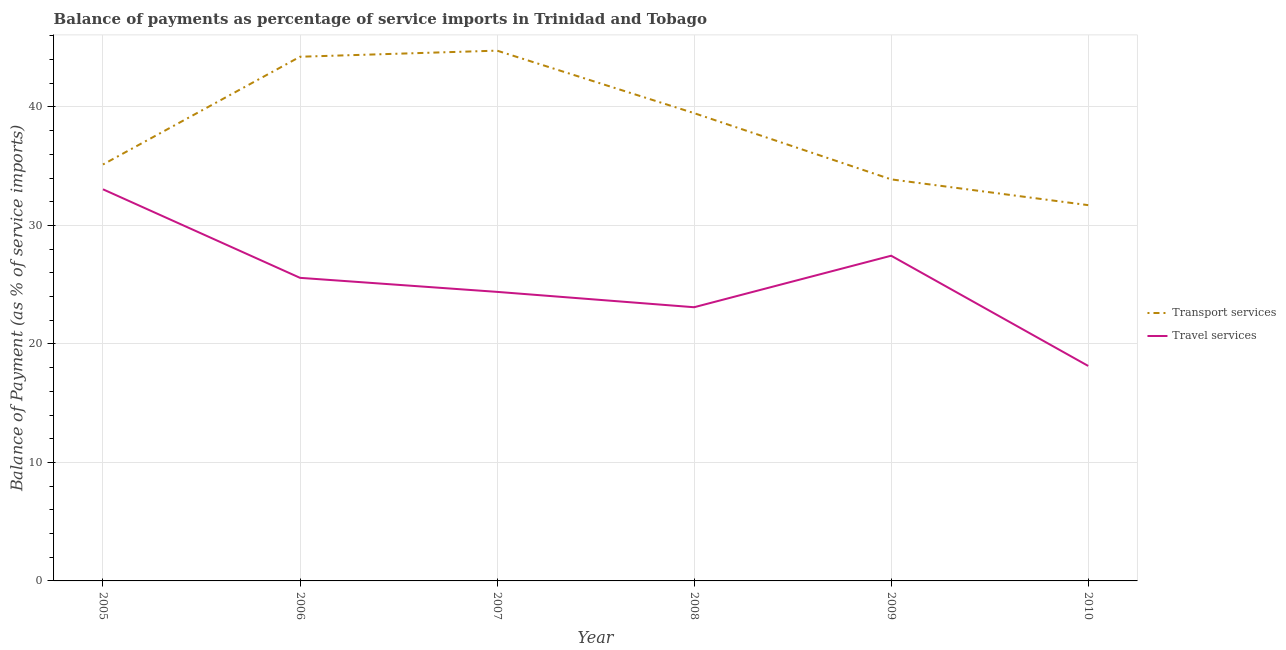Does the line corresponding to balance of payments of transport services intersect with the line corresponding to balance of payments of travel services?
Keep it short and to the point. No. Is the number of lines equal to the number of legend labels?
Keep it short and to the point. Yes. What is the balance of payments of travel services in 2009?
Provide a short and direct response. 27.45. Across all years, what is the maximum balance of payments of travel services?
Provide a short and direct response. 33.05. Across all years, what is the minimum balance of payments of transport services?
Your response must be concise. 31.71. What is the total balance of payments of travel services in the graph?
Ensure brevity in your answer.  151.71. What is the difference between the balance of payments of transport services in 2008 and that in 2009?
Provide a succinct answer. 5.59. What is the difference between the balance of payments of transport services in 2010 and the balance of payments of travel services in 2009?
Give a very brief answer. 4.27. What is the average balance of payments of travel services per year?
Offer a very short reply. 25.29. In the year 2008, what is the difference between the balance of payments of travel services and balance of payments of transport services?
Ensure brevity in your answer.  -16.38. In how many years, is the balance of payments of transport services greater than 10 %?
Give a very brief answer. 6. What is the ratio of the balance of payments of transport services in 2007 to that in 2008?
Your response must be concise. 1.13. Is the difference between the balance of payments of travel services in 2006 and 2007 greater than the difference between the balance of payments of transport services in 2006 and 2007?
Ensure brevity in your answer.  Yes. What is the difference between the highest and the second highest balance of payments of transport services?
Provide a short and direct response. 0.51. What is the difference between the highest and the lowest balance of payments of transport services?
Offer a very short reply. 13.04. Is the sum of the balance of payments of travel services in 2009 and 2010 greater than the maximum balance of payments of transport services across all years?
Your answer should be compact. Yes. Does the balance of payments of travel services monotonically increase over the years?
Your answer should be compact. No. Is the balance of payments of transport services strictly less than the balance of payments of travel services over the years?
Your answer should be compact. No. How many lines are there?
Offer a very short reply. 2. Are the values on the major ticks of Y-axis written in scientific E-notation?
Your response must be concise. No. Does the graph contain any zero values?
Make the answer very short. No. How are the legend labels stacked?
Your answer should be very brief. Vertical. What is the title of the graph?
Offer a terse response. Balance of payments as percentage of service imports in Trinidad and Tobago. Does "Travel Items" appear as one of the legend labels in the graph?
Offer a terse response. No. What is the label or title of the X-axis?
Make the answer very short. Year. What is the label or title of the Y-axis?
Offer a very short reply. Balance of Payment (as % of service imports). What is the Balance of Payment (as % of service imports) of Transport services in 2005?
Give a very brief answer. 35.15. What is the Balance of Payment (as % of service imports) of Travel services in 2005?
Provide a short and direct response. 33.05. What is the Balance of Payment (as % of service imports) in Transport services in 2006?
Provide a succinct answer. 44.24. What is the Balance of Payment (as % of service imports) in Travel services in 2006?
Provide a short and direct response. 25.58. What is the Balance of Payment (as % of service imports) in Transport services in 2007?
Your response must be concise. 44.75. What is the Balance of Payment (as % of service imports) in Travel services in 2007?
Keep it short and to the point. 24.39. What is the Balance of Payment (as % of service imports) of Transport services in 2008?
Offer a terse response. 39.48. What is the Balance of Payment (as % of service imports) of Travel services in 2008?
Ensure brevity in your answer.  23.1. What is the Balance of Payment (as % of service imports) of Transport services in 2009?
Offer a terse response. 33.89. What is the Balance of Payment (as % of service imports) in Travel services in 2009?
Offer a very short reply. 27.45. What is the Balance of Payment (as % of service imports) in Transport services in 2010?
Your response must be concise. 31.71. What is the Balance of Payment (as % of service imports) of Travel services in 2010?
Offer a very short reply. 18.14. Across all years, what is the maximum Balance of Payment (as % of service imports) in Transport services?
Your answer should be very brief. 44.75. Across all years, what is the maximum Balance of Payment (as % of service imports) in Travel services?
Provide a succinct answer. 33.05. Across all years, what is the minimum Balance of Payment (as % of service imports) in Transport services?
Your answer should be compact. 31.71. Across all years, what is the minimum Balance of Payment (as % of service imports) of Travel services?
Your answer should be very brief. 18.14. What is the total Balance of Payment (as % of service imports) of Transport services in the graph?
Your answer should be very brief. 229.22. What is the total Balance of Payment (as % of service imports) in Travel services in the graph?
Keep it short and to the point. 151.71. What is the difference between the Balance of Payment (as % of service imports) of Transport services in 2005 and that in 2006?
Offer a terse response. -9.09. What is the difference between the Balance of Payment (as % of service imports) in Travel services in 2005 and that in 2006?
Offer a very short reply. 7.47. What is the difference between the Balance of Payment (as % of service imports) in Transport services in 2005 and that in 2007?
Provide a succinct answer. -9.61. What is the difference between the Balance of Payment (as % of service imports) in Travel services in 2005 and that in 2007?
Your response must be concise. 8.66. What is the difference between the Balance of Payment (as % of service imports) in Transport services in 2005 and that in 2008?
Your response must be concise. -4.33. What is the difference between the Balance of Payment (as % of service imports) of Travel services in 2005 and that in 2008?
Your answer should be very brief. 9.95. What is the difference between the Balance of Payment (as % of service imports) in Transport services in 2005 and that in 2009?
Provide a succinct answer. 1.26. What is the difference between the Balance of Payment (as % of service imports) in Travel services in 2005 and that in 2009?
Your response must be concise. 5.61. What is the difference between the Balance of Payment (as % of service imports) in Transport services in 2005 and that in 2010?
Provide a short and direct response. 3.43. What is the difference between the Balance of Payment (as % of service imports) of Travel services in 2005 and that in 2010?
Ensure brevity in your answer.  14.91. What is the difference between the Balance of Payment (as % of service imports) in Transport services in 2006 and that in 2007?
Make the answer very short. -0.51. What is the difference between the Balance of Payment (as % of service imports) in Travel services in 2006 and that in 2007?
Your answer should be compact. 1.18. What is the difference between the Balance of Payment (as % of service imports) in Transport services in 2006 and that in 2008?
Provide a short and direct response. 4.76. What is the difference between the Balance of Payment (as % of service imports) of Travel services in 2006 and that in 2008?
Offer a very short reply. 2.48. What is the difference between the Balance of Payment (as % of service imports) of Transport services in 2006 and that in 2009?
Provide a short and direct response. 10.35. What is the difference between the Balance of Payment (as % of service imports) in Travel services in 2006 and that in 2009?
Provide a short and direct response. -1.87. What is the difference between the Balance of Payment (as % of service imports) of Transport services in 2006 and that in 2010?
Make the answer very short. 12.53. What is the difference between the Balance of Payment (as % of service imports) of Travel services in 2006 and that in 2010?
Offer a very short reply. 7.43. What is the difference between the Balance of Payment (as % of service imports) of Transport services in 2007 and that in 2008?
Your answer should be compact. 5.28. What is the difference between the Balance of Payment (as % of service imports) in Travel services in 2007 and that in 2008?
Provide a short and direct response. 1.3. What is the difference between the Balance of Payment (as % of service imports) in Transport services in 2007 and that in 2009?
Your response must be concise. 10.86. What is the difference between the Balance of Payment (as % of service imports) of Travel services in 2007 and that in 2009?
Offer a very short reply. -3.05. What is the difference between the Balance of Payment (as % of service imports) of Transport services in 2007 and that in 2010?
Provide a succinct answer. 13.04. What is the difference between the Balance of Payment (as % of service imports) in Travel services in 2007 and that in 2010?
Provide a succinct answer. 6.25. What is the difference between the Balance of Payment (as % of service imports) of Transport services in 2008 and that in 2009?
Offer a very short reply. 5.59. What is the difference between the Balance of Payment (as % of service imports) in Travel services in 2008 and that in 2009?
Provide a short and direct response. -4.35. What is the difference between the Balance of Payment (as % of service imports) in Transport services in 2008 and that in 2010?
Ensure brevity in your answer.  7.76. What is the difference between the Balance of Payment (as % of service imports) of Travel services in 2008 and that in 2010?
Offer a very short reply. 4.95. What is the difference between the Balance of Payment (as % of service imports) of Transport services in 2009 and that in 2010?
Your answer should be compact. 2.18. What is the difference between the Balance of Payment (as % of service imports) of Travel services in 2009 and that in 2010?
Your answer should be very brief. 9.3. What is the difference between the Balance of Payment (as % of service imports) of Transport services in 2005 and the Balance of Payment (as % of service imports) of Travel services in 2006?
Make the answer very short. 9.57. What is the difference between the Balance of Payment (as % of service imports) in Transport services in 2005 and the Balance of Payment (as % of service imports) in Travel services in 2007?
Offer a terse response. 10.75. What is the difference between the Balance of Payment (as % of service imports) in Transport services in 2005 and the Balance of Payment (as % of service imports) in Travel services in 2008?
Ensure brevity in your answer.  12.05. What is the difference between the Balance of Payment (as % of service imports) in Transport services in 2005 and the Balance of Payment (as % of service imports) in Travel services in 2009?
Your answer should be very brief. 7.7. What is the difference between the Balance of Payment (as % of service imports) of Transport services in 2005 and the Balance of Payment (as % of service imports) of Travel services in 2010?
Offer a terse response. 17. What is the difference between the Balance of Payment (as % of service imports) in Transport services in 2006 and the Balance of Payment (as % of service imports) in Travel services in 2007?
Give a very brief answer. 19.84. What is the difference between the Balance of Payment (as % of service imports) of Transport services in 2006 and the Balance of Payment (as % of service imports) of Travel services in 2008?
Offer a very short reply. 21.14. What is the difference between the Balance of Payment (as % of service imports) of Transport services in 2006 and the Balance of Payment (as % of service imports) of Travel services in 2009?
Offer a very short reply. 16.79. What is the difference between the Balance of Payment (as % of service imports) of Transport services in 2006 and the Balance of Payment (as % of service imports) of Travel services in 2010?
Your answer should be very brief. 26.09. What is the difference between the Balance of Payment (as % of service imports) in Transport services in 2007 and the Balance of Payment (as % of service imports) in Travel services in 2008?
Give a very brief answer. 21.66. What is the difference between the Balance of Payment (as % of service imports) of Transport services in 2007 and the Balance of Payment (as % of service imports) of Travel services in 2009?
Keep it short and to the point. 17.31. What is the difference between the Balance of Payment (as % of service imports) of Transport services in 2007 and the Balance of Payment (as % of service imports) of Travel services in 2010?
Keep it short and to the point. 26.61. What is the difference between the Balance of Payment (as % of service imports) of Transport services in 2008 and the Balance of Payment (as % of service imports) of Travel services in 2009?
Ensure brevity in your answer.  12.03. What is the difference between the Balance of Payment (as % of service imports) in Transport services in 2008 and the Balance of Payment (as % of service imports) in Travel services in 2010?
Ensure brevity in your answer.  21.33. What is the difference between the Balance of Payment (as % of service imports) in Transport services in 2009 and the Balance of Payment (as % of service imports) in Travel services in 2010?
Give a very brief answer. 15.75. What is the average Balance of Payment (as % of service imports) of Transport services per year?
Give a very brief answer. 38.2. What is the average Balance of Payment (as % of service imports) in Travel services per year?
Provide a short and direct response. 25.29. In the year 2005, what is the difference between the Balance of Payment (as % of service imports) of Transport services and Balance of Payment (as % of service imports) of Travel services?
Ensure brevity in your answer.  2.09. In the year 2006, what is the difference between the Balance of Payment (as % of service imports) in Transport services and Balance of Payment (as % of service imports) in Travel services?
Provide a succinct answer. 18.66. In the year 2007, what is the difference between the Balance of Payment (as % of service imports) in Transport services and Balance of Payment (as % of service imports) in Travel services?
Ensure brevity in your answer.  20.36. In the year 2008, what is the difference between the Balance of Payment (as % of service imports) in Transport services and Balance of Payment (as % of service imports) in Travel services?
Your answer should be very brief. 16.38. In the year 2009, what is the difference between the Balance of Payment (as % of service imports) of Transport services and Balance of Payment (as % of service imports) of Travel services?
Your answer should be compact. 6.44. In the year 2010, what is the difference between the Balance of Payment (as % of service imports) in Transport services and Balance of Payment (as % of service imports) in Travel services?
Your answer should be very brief. 13.57. What is the ratio of the Balance of Payment (as % of service imports) of Transport services in 2005 to that in 2006?
Give a very brief answer. 0.79. What is the ratio of the Balance of Payment (as % of service imports) of Travel services in 2005 to that in 2006?
Keep it short and to the point. 1.29. What is the ratio of the Balance of Payment (as % of service imports) in Transport services in 2005 to that in 2007?
Provide a short and direct response. 0.79. What is the ratio of the Balance of Payment (as % of service imports) in Travel services in 2005 to that in 2007?
Make the answer very short. 1.35. What is the ratio of the Balance of Payment (as % of service imports) in Transport services in 2005 to that in 2008?
Give a very brief answer. 0.89. What is the ratio of the Balance of Payment (as % of service imports) in Travel services in 2005 to that in 2008?
Offer a very short reply. 1.43. What is the ratio of the Balance of Payment (as % of service imports) in Travel services in 2005 to that in 2009?
Give a very brief answer. 1.2. What is the ratio of the Balance of Payment (as % of service imports) in Transport services in 2005 to that in 2010?
Your answer should be very brief. 1.11. What is the ratio of the Balance of Payment (as % of service imports) in Travel services in 2005 to that in 2010?
Your response must be concise. 1.82. What is the ratio of the Balance of Payment (as % of service imports) in Travel services in 2006 to that in 2007?
Keep it short and to the point. 1.05. What is the ratio of the Balance of Payment (as % of service imports) of Transport services in 2006 to that in 2008?
Ensure brevity in your answer.  1.12. What is the ratio of the Balance of Payment (as % of service imports) of Travel services in 2006 to that in 2008?
Make the answer very short. 1.11. What is the ratio of the Balance of Payment (as % of service imports) of Transport services in 2006 to that in 2009?
Give a very brief answer. 1.31. What is the ratio of the Balance of Payment (as % of service imports) of Travel services in 2006 to that in 2009?
Your answer should be very brief. 0.93. What is the ratio of the Balance of Payment (as % of service imports) of Transport services in 2006 to that in 2010?
Offer a very short reply. 1.39. What is the ratio of the Balance of Payment (as % of service imports) in Travel services in 2006 to that in 2010?
Provide a short and direct response. 1.41. What is the ratio of the Balance of Payment (as % of service imports) of Transport services in 2007 to that in 2008?
Offer a terse response. 1.13. What is the ratio of the Balance of Payment (as % of service imports) in Travel services in 2007 to that in 2008?
Keep it short and to the point. 1.06. What is the ratio of the Balance of Payment (as % of service imports) in Transport services in 2007 to that in 2009?
Offer a terse response. 1.32. What is the ratio of the Balance of Payment (as % of service imports) of Travel services in 2007 to that in 2009?
Offer a very short reply. 0.89. What is the ratio of the Balance of Payment (as % of service imports) of Transport services in 2007 to that in 2010?
Keep it short and to the point. 1.41. What is the ratio of the Balance of Payment (as % of service imports) in Travel services in 2007 to that in 2010?
Your answer should be very brief. 1.34. What is the ratio of the Balance of Payment (as % of service imports) of Transport services in 2008 to that in 2009?
Your answer should be very brief. 1.16. What is the ratio of the Balance of Payment (as % of service imports) in Travel services in 2008 to that in 2009?
Your response must be concise. 0.84. What is the ratio of the Balance of Payment (as % of service imports) in Transport services in 2008 to that in 2010?
Make the answer very short. 1.24. What is the ratio of the Balance of Payment (as % of service imports) of Travel services in 2008 to that in 2010?
Your answer should be compact. 1.27. What is the ratio of the Balance of Payment (as % of service imports) of Transport services in 2009 to that in 2010?
Your answer should be very brief. 1.07. What is the ratio of the Balance of Payment (as % of service imports) in Travel services in 2009 to that in 2010?
Ensure brevity in your answer.  1.51. What is the difference between the highest and the second highest Balance of Payment (as % of service imports) of Transport services?
Offer a very short reply. 0.51. What is the difference between the highest and the second highest Balance of Payment (as % of service imports) in Travel services?
Your answer should be very brief. 5.61. What is the difference between the highest and the lowest Balance of Payment (as % of service imports) of Transport services?
Your answer should be compact. 13.04. What is the difference between the highest and the lowest Balance of Payment (as % of service imports) in Travel services?
Your answer should be compact. 14.91. 